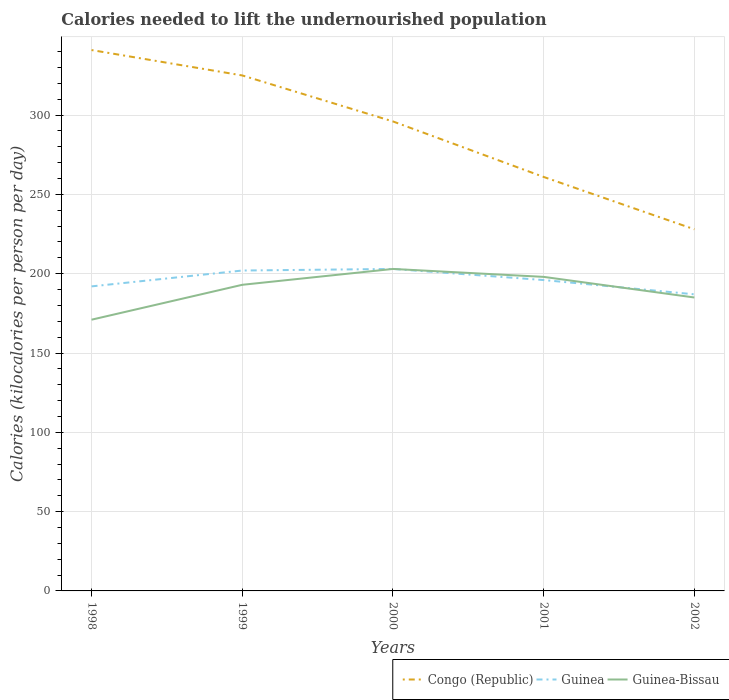How many different coloured lines are there?
Offer a terse response. 3. Across all years, what is the maximum total calories needed to lift the undernourished population in Guinea?
Ensure brevity in your answer.  187. In which year was the total calories needed to lift the undernourished population in Guinea maximum?
Your answer should be compact. 2002. What is the total total calories needed to lift the undernourished population in Guinea-Bissau in the graph?
Your response must be concise. 13. What is the difference between the highest and the second highest total calories needed to lift the undernourished population in Congo (Republic)?
Ensure brevity in your answer.  113. What is the difference between the highest and the lowest total calories needed to lift the undernourished population in Guinea?
Keep it short and to the point. 2. How many lines are there?
Provide a succinct answer. 3. What is the difference between two consecutive major ticks on the Y-axis?
Provide a short and direct response. 50. Are the values on the major ticks of Y-axis written in scientific E-notation?
Your answer should be very brief. No. Where does the legend appear in the graph?
Provide a succinct answer. Bottom right. How are the legend labels stacked?
Make the answer very short. Horizontal. What is the title of the graph?
Provide a succinct answer. Calories needed to lift the undernourished population. What is the label or title of the X-axis?
Make the answer very short. Years. What is the label or title of the Y-axis?
Your answer should be very brief. Calories (kilocalories per person per day). What is the Calories (kilocalories per person per day) in Congo (Republic) in 1998?
Offer a very short reply. 341. What is the Calories (kilocalories per person per day) in Guinea in 1998?
Your answer should be very brief. 192. What is the Calories (kilocalories per person per day) in Guinea-Bissau in 1998?
Offer a very short reply. 171. What is the Calories (kilocalories per person per day) of Congo (Republic) in 1999?
Offer a very short reply. 325. What is the Calories (kilocalories per person per day) of Guinea in 1999?
Keep it short and to the point. 202. What is the Calories (kilocalories per person per day) in Guinea-Bissau in 1999?
Give a very brief answer. 193. What is the Calories (kilocalories per person per day) of Congo (Republic) in 2000?
Your response must be concise. 296. What is the Calories (kilocalories per person per day) of Guinea in 2000?
Your answer should be very brief. 203. What is the Calories (kilocalories per person per day) of Guinea-Bissau in 2000?
Give a very brief answer. 203. What is the Calories (kilocalories per person per day) of Congo (Republic) in 2001?
Give a very brief answer. 261. What is the Calories (kilocalories per person per day) in Guinea in 2001?
Keep it short and to the point. 196. What is the Calories (kilocalories per person per day) in Guinea-Bissau in 2001?
Your answer should be compact. 198. What is the Calories (kilocalories per person per day) of Congo (Republic) in 2002?
Keep it short and to the point. 228. What is the Calories (kilocalories per person per day) of Guinea in 2002?
Your answer should be very brief. 187. What is the Calories (kilocalories per person per day) in Guinea-Bissau in 2002?
Your answer should be compact. 185. Across all years, what is the maximum Calories (kilocalories per person per day) of Congo (Republic)?
Keep it short and to the point. 341. Across all years, what is the maximum Calories (kilocalories per person per day) of Guinea?
Provide a succinct answer. 203. Across all years, what is the maximum Calories (kilocalories per person per day) of Guinea-Bissau?
Give a very brief answer. 203. Across all years, what is the minimum Calories (kilocalories per person per day) of Congo (Republic)?
Make the answer very short. 228. Across all years, what is the minimum Calories (kilocalories per person per day) in Guinea?
Your answer should be very brief. 187. Across all years, what is the minimum Calories (kilocalories per person per day) in Guinea-Bissau?
Ensure brevity in your answer.  171. What is the total Calories (kilocalories per person per day) of Congo (Republic) in the graph?
Your response must be concise. 1451. What is the total Calories (kilocalories per person per day) in Guinea in the graph?
Offer a terse response. 980. What is the total Calories (kilocalories per person per day) in Guinea-Bissau in the graph?
Provide a short and direct response. 950. What is the difference between the Calories (kilocalories per person per day) of Congo (Republic) in 1998 and that in 1999?
Ensure brevity in your answer.  16. What is the difference between the Calories (kilocalories per person per day) of Guinea-Bissau in 1998 and that in 1999?
Offer a terse response. -22. What is the difference between the Calories (kilocalories per person per day) of Congo (Republic) in 1998 and that in 2000?
Make the answer very short. 45. What is the difference between the Calories (kilocalories per person per day) in Guinea-Bissau in 1998 and that in 2000?
Offer a very short reply. -32. What is the difference between the Calories (kilocalories per person per day) of Congo (Republic) in 1998 and that in 2001?
Make the answer very short. 80. What is the difference between the Calories (kilocalories per person per day) of Congo (Republic) in 1998 and that in 2002?
Provide a succinct answer. 113. What is the difference between the Calories (kilocalories per person per day) of Guinea-Bissau in 1998 and that in 2002?
Offer a terse response. -14. What is the difference between the Calories (kilocalories per person per day) of Guinea in 1999 and that in 2000?
Provide a short and direct response. -1. What is the difference between the Calories (kilocalories per person per day) in Guinea-Bissau in 1999 and that in 2000?
Provide a short and direct response. -10. What is the difference between the Calories (kilocalories per person per day) in Congo (Republic) in 1999 and that in 2002?
Your answer should be very brief. 97. What is the difference between the Calories (kilocalories per person per day) of Guinea-Bissau in 1999 and that in 2002?
Offer a terse response. 8. What is the difference between the Calories (kilocalories per person per day) of Congo (Republic) in 2000 and that in 2001?
Your answer should be very brief. 35. What is the difference between the Calories (kilocalories per person per day) of Congo (Republic) in 2000 and that in 2002?
Offer a terse response. 68. What is the difference between the Calories (kilocalories per person per day) in Congo (Republic) in 2001 and that in 2002?
Your answer should be very brief. 33. What is the difference between the Calories (kilocalories per person per day) of Guinea in 2001 and that in 2002?
Give a very brief answer. 9. What is the difference between the Calories (kilocalories per person per day) of Guinea-Bissau in 2001 and that in 2002?
Keep it short and to the point. 13. What is the difference between the Calories (kilocalories per person per day) of Congo (Republic) in 1998 and the Calories (kilocalories per person per day) of Guinea in 1999?
Provide a short and direct response. 139. What is the difference between the Calories (kilocalories per person per day) of Congo (Republic) in 1998 and the Calories (kilocalories per person per day) of Guinea-Bissau in 1999?
Make the answer very short. 148. What is the difference between the Calories (kilocalories per person per day) of Guinea in 1998 and the Calories (kilocalories per person per day) of Guinea-Bissau in 1999?
Your answer should be very brief. -1. What is the difference between the Calories (kilocalories per person per day) in Congo (Republic) in 1998 and the Calories (kilocalories per person per day) in Guinea in 2000?
Give a very brief answer. 138. What is the difference between the Calories (kilocalories per person per day) in Congo (Republic) in 1998 and the Calories (kilocalories per person per day) in Guinea-Bissau in 2000?
Offer a very short reply. 138. What is the difference between the Calories (kilocalories per person per day) in Guinea in 1998 and the Calories (kilocalories per person per day) in Guinea-Bissau in 2000?
Your answer should be very brief. -11. What is the difference between the Calories (kilocalories per person per day) in Congo (Republic) in 1998 and the Calories (kilocalories per person per day) in Guinea in 2001?
Give a very brief answer. 145. What is the difference between the Calories (kilocalories per person per day) of Congo (Republic) in 1998 and the Calories (kilocalories per person per day) of Guinea-Bissau in 2001?
Your answer should be compact. 143. What is the difference between the Calories (kilocalories per person per day) of Congo (Republic) in 1998 and the Calories (kilocalories per person per day) of Guinea in 2002?
Your answer should be very brief. 154. What is the difference between the Calories (kilocalories per person per day) of Congo (Republic) in 1998 and the Calories (kilocalories per person per day) of Guinea-Bissau in 2002?
Offer a very short reply. 156. What is the difference between the Calories (kilocalories per person per day) in Congo (Republic) in 1999 and the Calories (kilocalories per person per day) in Guinea in 2000?
Make the answer very short. 122. What is the difference between the Calories (kilocalories per person per day) of Congo (Republic) in 1999 and the Calories (kilocalories per person per day) of Guinea-Bissau in 2000?
Ensure brevity in your answer.  122. What is the difference between the Calories (kilocalories per person per day) of Congo (Republic) in 1999 and the Calories (kilocalories per person per day) of Guinea in 2001?
Your response must be concise. 129. What is the difference between the Calories (kilocalories per person per day) of Congo (Republic) in 1999 and the Calories (kilocalories per person per day) of Guinea-Bissau in 2001?
Offer a very short reply. 127. What is the difference between the Calories (kilocalories per person per day) in Guinea in 1999 and the Calories (kilocalories per person per day) in Guinea-Bissau in 2001?
Offer a terse response. 4. What is the difference between the Calories (kilocalories per person per day) in Congo (Republic) in 1999 and the Calories (kilocalories per person per day) in Guinea in 2002?
Provide a succinct answer. 138. What is the difference between the Calories (kilocalories per person per day) of Congo (Republic) in 1999 and the Calories (kilocalories per person per day) of Guinea-Bissau in 2002?
Make the answer very short. 140. What is the difference between the Calories (kilocalories per person per day) in Congo (Republic) in 2000 and the Calories (kilocalories per person per day) in Guinea in 2001?
Give a very brief answer. 100. What is the difference between the Calories (kilocalories per person per day) in Guinea in 2000 and the Calories (kilocalories per person per day) in Guinea-Bissau in 2001?
Offer a very short reply. 5. What is the difference between the Calories (kilocalories per person per day) of Congo (Republic) in 2000 and the Calories (kilocalories per person per day) of Guinea in 2002?
Your answer should be very brief. 109. What is the difference between the Calories (kilocalories per person per day) in Congo (Republic) in 2000 and the Calories (kilocalories per person per day) in Guinea-Bissau in 2002?
Ensure brevity in your answer.  111. What is the difference between the Calories (kilocalories per person per day) of Congo (Republic) in 2001 and the Calories (kilocalories per person per day) of Guinea-Bissau in 2002?
Give a very brief answer. 76. What is the average Calories (kilocalories per person per day) of Congo (Republic) per year?
Give a very brief answer. 290.2. What is the average Calories (kilocalories per person per day) in Guinea per year?
Give a very brief answer. 196. What is the average Calories (kilocalories per person per day) in Guinea-Bissau per year?
Keep it short and to the point. 190. In the year 1998, what is the difference between the Calories (kilocalories per person per day) of Congo (Republic) and Calories (kilocalories per person per day) of Guinea?
Your answer should be compact. 149. In the year 1998, what is the difference between the Calories (kilocalories per person per day) of Congo (Republic) and Calories (kilocalories per person per day) of Guinea-Bissau?
Offer a very short reply. 170. In the year 1998, what is the difference between the Calories (kilocalories per person per day) of Guinea and Calories (kilocalories per person per day) of Guinea-Bissau?
Ensure brevity in your answer.  21. In the year 1999, what is the difference between the Calories (kilocalories per person per day) in Congo (Republic) and Calories (kilocalories per person per day) in Guinea?
Give a very brief answer. 123. In the year 1999, what is the difference between the Calories (kilocalories per person per day) of Congo (Republic) and Calories (kilocalories per person per day) of Guinea-Bissau?
Provide a succinct answer. 132. In the year 1999, what is the difference between the Calories (kilocalories per person per day) in Guinea and Calories (kilocalories per person per day) in Guinea-Bissau?
Offer a very short reply. 9. In the year 2000, what is the difference between the Calories (kilocalories per person per day) of Congo (Republic) and Calories (kilocalories per person per day) of Guinea?
Provide a succinct answer. 93. In the year 2000, what is the difference between the Calories (kilocalories per person per day) in Congo (Republic) and Calories (kilocalories per person per day) in Guinea-Bissau?
Provide a succinct answer. 93. In the year 2001, what is the difference between the Calories (kilocalories per person per day) in Congo (Republic) and Calories (kilocalories per person per day) in Guinea?
Your response must be concise. 65. In the year 2001, what is the difference between the Calories (kilocalories per person per day) in Congo (Republic) and Calories (kilocalories per person per day) in Guinea-Bissau?
Your answer should be compact. 63. In the year 2001, what is the difference between the Calories (kilocalories per person per day) of Guinea and Calories (kilocalories per person per day) of Guinea-Bissau?
Provide a succinct answer. -2. In the year 2002, what is the difference between the Calories (kilocalories per person per day) of Congo (Republic) and Calories (kilocalories per person per day) of Guinea?
Ensure brevity in your answer.  41. In the year 2002, what is the difference between the Calories (kilocalories per person per day) in Congo (Republic) and Calories (kilocalories per person per day) in Guinea-Bissau?
Offer a very short reply. 43. What is the ratio of the Calories (kilocalories per person per day) of Congo (Republic) in 1998 to that in 1999?
Ensure brevity in your answer.  1.05. What is the ratio of the Calories (kilocalories per person per day) in Guinea in 1998 to that in 1999?
Your response must be concise. 0.95. What is the ratio of the Calories (kilocalories per person per day) of Guinea-Bissau in 1998 to that in 1999?
Your answer should be very brief. 0.89. What is the ratio of the Calories (kilocalories per person per day) in Congo (Republic) in 1998 to that in 2000?
Keep it short and to the point. 1.15. What is the ratio of the Calories (kilocalories per person per day) in Guinea in 1998 to that in 2000?
Provide a short and direct response. 0.95. What is the ratio of the Calories (kilocalories per person per day) of Guinea-Bissau in 1998 to that in 2000?
Make the answer very short. 0.84. What is the ratio of the Calories (kilocalories per person per day) of Congo (Republic) in 1998 to that in 2001?
Keep it short and to the point. 1.31. What is the ratio of the Calories (kilocalories per person per day) of Guinea in 1998 to that in 2001?
Offer a terse response. 0.98. What is the ratio of the Calories (kilocalories per person per day) in Guinea-Bissau in 1998 to that in 2001?
Provide a short and direct response. 0.86. What is the ratio of the Calories (kilocalories per person per day) of Congo (Republic) in 1998 to that in 2002?
Offer a very short reply. 1.5. What is the ratio of the Calories (kilocalories per person per day) in Guinea in 1998 to that in 2002?
Keep it short and to the point. 1.03. What is the ratio of the Calories (kilocalories per person per day) of Guinea-Bissau in 1998 to that in 2002?
Your response must be concise. 0.92. What is the ratio of the Calories (kilocalories per person per day) of Congo (Republic) in 1999 to that in 2000?
Your response must be concise. 1.1. What is the ratio of the Calories (kilocalories per person per day) of Guinea-Bissau in 1999 to that in 2000?
Ensure brevity in your answer.  0.95. What is the ratio of the Calories (kilocalories per person per day) of Congo (Republic) in 1999 to that in 2001?
Provide a short and direct response. 1.25. What is the ratio of the Calories (kilocalories per person per day) of Guinea in 1999 to that in 2001?
Provide a short and direct response. 1.03. What is the ratio of the Calories (kilocalories per person per day) of Guinea-Bissau in 1999 to that in 2001?
Make the answer very short. 0.97. What is the ratio of the Calories (kilocalories per person per day) in Congo (Republic) in 1999 to that in 2002?
Your response must be concise. 1.43. What is the ratio of the Calories (kilocalories per person per day) of Guinea in 1999 to that in 2002?
Your answer should be very brief. 1.08. What is the ratio of the Calories (kilocalories per person per day) of Guinea-Bissau in 1999 to that in 2002?
Keep it short and to the point. 1.04. What is the ratio of the Calories (kilocalories per person per day) of Congo (Republic) in 2000 to that in 2001?
Ensure brevity in your answer.  1.13. What is the ratio of the Calories (kilocalories per person per day) in Guinea in 2000 to that in 2001?
Your answer should be compact. 1.04. What is the ratio of the Calories (kilocalories per person per day) of Guinea-Bissau in 2000 to that in 2001?
Keep it short and to the point. 1.03. What is the ratio of the Calories (kilocalories per person per day) in Congo (Republic) in 2000 to that in 2002?
Your answer should be compact. 1.3. What is the ratio of the Calories (kilocalories per person per day) in Guinea in 2000 to that in 2002?
Keep it short and to the point. 1.09. What is the ratio of the Calories (kilocalories per person per day) in Guinea-Bissau in 2000 to that in 2002?
Provide a succinct answer. 1.1. What is the ratio of the Calories (kilocalories per person per day) in Congo (Republic) in 2001 to that in 2002?
Provide a short and direct response. 1.14. What is the ratio of the Calories (kilocalories per person per day) of Guinea in 2001 to that in 2002?
Offer a very short reply. 1.05. What is the ratio of the Calories (kilocalories per person per day) in Guinea-Bissau in 2001 to that in 2002?
Ensure brevity in your answer.  1.07. What is the difference between the highest and the second highest Calories (kilocalories per person per day) of Congo (Republic)?
Make the answer very short. 16. What is the difference between the highest and the second highest Calories (kilocalories per person per day) of Guinea-Bissau?
Keep it short and to the point. 5. What is the difference between the highest and the lowest Calories (kilocalories per person per day) in Congo (Republic)?
Provide a short and direct response. 113. What is the difference between the highest and the lowest Calories (kilocalories per person per day) of Guinea?
Offer a very short reply. 16. What is the difference between the highest and the lowest Calories (kilocalories per person per day) in Guinea-Bissau?
Your answer should be compact. 32. 